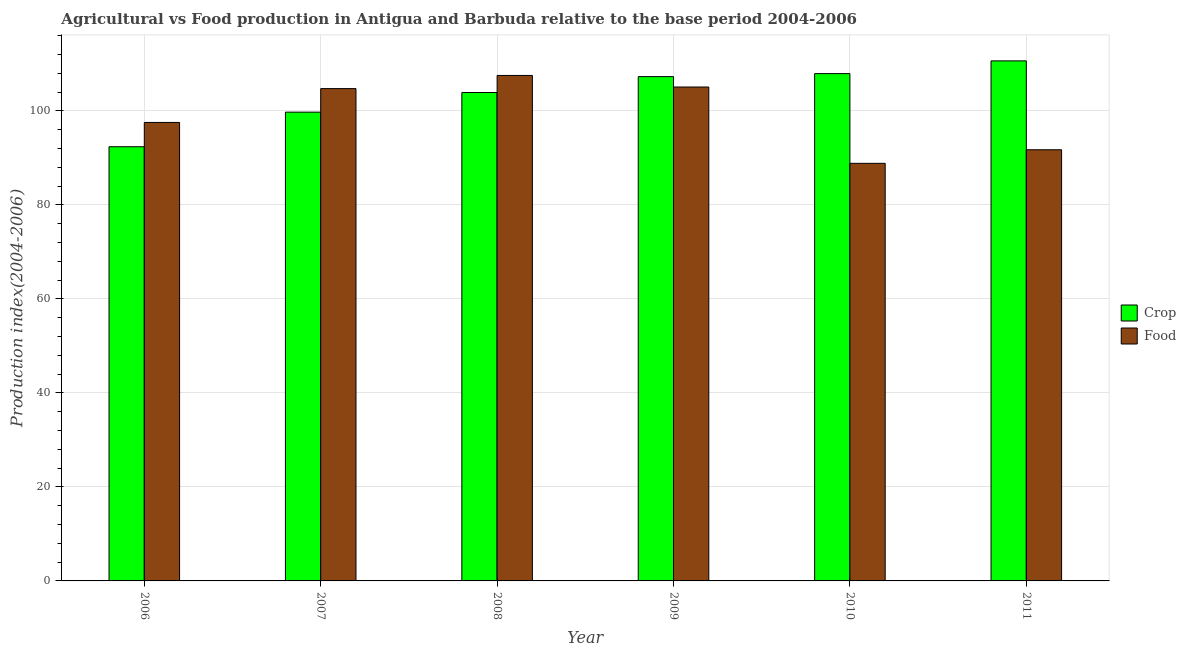How many different coloured bars are there?
Ensure brevity in your answer.  2. How many groups of bars are there?
Give a very brief answer. 6. Are the number of bars per tick equal to the number of legend labels?
Ensure brevity in your answer.  Yes. Are the number of bars on each tick of the X-axis equal?
Make the answer very short. Yes. How many bars are there on the 3rd tick from the left?
Ensure brevity in your answer.  2. What is the label of the 3rd group of bars from the left?
Make the answer very short. 2008. In how many cases, is the number of bars for a given year not equal to the number of legend labels?
Offer a terse response. 0. What is the food production index in 2007?
Your answer should be very brief. 104.75. Across all years, what is the maximum food production index?
Provide a succinct answer. 107.55. Across all years, what is the minimum food production index?
Provide a succinct answer. 88.85. What is the total food production index in the graph?
Keep it short and to the point. 595.53. What is the difference between the food production index in 2006 and that in 2011?
Offer a terse response. 5.81. What is the difference between the food production index in 2011 and the crop production index in 2006?
Make the answer very short. -5.81. What is the average food production index per year?
Ensure brevity in your answer.  99.26. In the year 2011, what is the difference between the food production index and crop production index?
Offer a very short reply. 0. What is the ratio of the food production index in 2006 to that in 2011?
Provide a succinct answer. 1.06. Is the crop production index in 2010 less than that in 2011?
Give a very brief answer. Yes. What is the difference between the highest and the second highest food production index?
Offer a terse response. 2.46. What is the difference between the highest and the lowest food production index?
Give a very brief answer. 18.7. What does the 1st bar from the left in 2010 represents?
Your answer should be very brief. Crop. What does the 1st bar from the right in 2007 represents?
Provide a short and direct response. Food. How many bars are there?
Your response must be concise. 12. Are the values on the major ticks of Y-axis written in scientific E-notation?
Keep it short and to the point. No. Does the graph contain any zero values?
Offer a very short reply. No. How are the legend labels stacked?
Make the answer very short. Vertical. What is the title of the graph?
Provide a succinct answer. Agricultural vs Food production in Antigua and Barbuda relative to the base period 2004-2006. Does "UN agencies" appear as one of the legend labels in the graph?
Give a very brief answer. No. What is the label or title of the Y-axis?
Give a very brief answer. Production index(2004-2006). What is the Production index(2004-2006) of Crop in 2006?
Your answer should be very brief. 92.38. What is the Production index(2004-2006) of Food in 2006?
Make the answer very short. 97.55. What is the Production index(2004-2006) in Crop in 2007?
Keep it short and to the point. 99.74. What is the Production index(2004-2006) of Food in 2007?
Your answer should be compact. 104.75. What is the Production index(2004-2006) in Crop in 2008?
Keep it short and to the point. 103.92. What is the Production index(2004-2006) in Food in 2008?
Ensure brevity in your answer.  107.55. What is the Production index(2004-2006) in Crop in 2009?
Ensure brevity in your answer.  107.3. What is the Production index(2004-2006) in Food in 2009?
Keep it short and to the point. 105.09. What is the Production index(2004-2006) of Crop in 2010?
Offer a terse response. 107.94. What is the Production index(2004-2006) in Food in 2010?
Your answer should be compact. 88.85. What is the Production index(2004-2006) of Crop in 2011?
Your response must be concise. 110.65. What is the Production index(2004-2006) in Food in 2011?
Give a very brief answer. 91.74. Across all years, what is the maximum Production index(2004-2006) in Crop?
Make the answer very short. 110.65. Across all years, what is the maximum Production index(2004-2006) of Food?
Your answer should be compact. 107.55. Across all years, what is the minimum Production index(2004-2006) of Crop?
Your answer should be very brief. 92.38. Across all years, what is the minimum Production index(2004-2006) of Food?
Give a very brief answer. 88.85. What is the total Production index(2004-2006) in Crop in the graph?
Your response must be concise. 621.93. What is the total Production index(2004-2006) in Food in the graph?
Ensure brevity in your answer.  595.53. What is the difference between the Production index(2004-2006) of Crop in 2006 and that in 2007?
Your answer should be compact. -7.36. What is the difference between the Production index(2004-2006) of Crop in 2006 and that in 2008?
Offer a terse response. -11.54. What is the difference between the Production index(2004-2006) of Crop in 2006 and that in 2009?
Offer a terse response. -14.92. What is the difference between the Production index(2004-2006) of Food in 2006 and that in 2009?
Your response must be concise. -7.54. What is the difference between the Production index(2004-2006) in Crop in 2006 and that in 2010?
Your response must be concise. -15.56. What is the difference between the Production index(2004-2006) of Food in 2006 and that in 2010?
Provide a short and direct response. 8.7. What is the difference between the Production index(2004-2006) in Crop in 2006 and that in 2011?
Ensure brevity in your answer.  -18.27. What is the difference between the Production index(2004-2006) in Food in 2006 and that in 2011?
Make the answer very short. 5.81. What is the difference between the Production index(2004-2006) in Crop in 2007 and that in 2008?
Ensure brevity in your answer.  -4.18. What is the difference between the Production index(2004-2006) in Crop in 2007 and that in 2009?
Give a very brief answer. -7.56. What is the difference between the Production index(2004-2006) of Food in 2007 and that in 2009?
Ensure brevity in your answer.  -0.34. What is the difference between the Production index(2004-2006) in Crop in 2007 and that in 2010?
Ensure brevity in your answer.  -8.2. What is the difference between the Production index(2004-2006) of Food in 2007 and that in 2010?
Keep it short and to the point. 15.9. What is the difference between the Production index(2004-2006) of Crop in 2007 and that in 2011?
Make the answer very short. -10.91. What is the difference between the Production index(2004-2006) of Food in 2007 and that in 2011?
Give a very brief answer. 13.01. What is the difference between the Production index(2004-2006) of Crop in 2008 and that in 2009?
Provide a short and direct response. -3.38. What is the difference between the Production index(2004-2006) in Food in 2008 and that in 2009?
Your answer should be very brief. 2.46. What is the difference between the Production index(2004-2006) in Crop in 2008 and that in 2010?
Your answer should be compact. -4.02. What is the difference between the Production index(2004-2006) of Crop in 2008 and that in 2011?
Give a very brief answer. -6.73. What is the difference between the Production index(2004-2006) in Food in 2008 and that in 2011?
Give a very brief answer. 15.81. What is the difference between the Production index(2004-2006) in Crop in 2009 and that in 2010?
Provide a short and direct response. -0.64. What is the difference between the Production index(2004-2006) in Food in 2009 and that in 2010?
Offer a very short reply. 16.24. What is the difference between the Production index(2004-2006) in Crop in 2009 and that in 2011?
Provide a short and direct response. -3.35. What is the difference between the Production index(2004-2006) in Food in 2009 and that in 2011?
Ensure brevity in your answer.  13.35. What is the difference between the Production index(2004-2006) in Crop in 2010 and that in 2011?
Ensure brevity in your answer.  -2.71. What is the difference between the Production index(2004-2006) of Food in 2010 and that in 2011?
Provide a short and direct response. -2.89. What is the difference between the Production index(2004-2006) in Crop in 2006 and the Production index(2004-2006) in Food in 2007?
Offer a terse response. -12.37. What is the difference between the Production index(2004-2006) of Crop in 2006 and the Production index(2004-2006) of Food in 2008?
Give a very brief answer. -15.17. What is the difference between the Production index(2004-2006) in Crop in 2006 and the Production index(2004-2006) in Food in 2009?
Make the answer very short. -12.71. What is the difference between the Production index(2004-2006) in Crop in 2006 and the Production index(2004-2006) in Food in 2010?
Keep it short and to the point. 3.53. What is the difference between the Production index(2004-2006) in Crop in 2006 and the Production index(2004-2006) in Food in 2011?
Keep it short and to the point. 0.64. What is the difference between the Production index(2004-2006) of Crop in 2007 and the Production index(2004-2006) of Food in 2008?
Your answer should be very brief. -7.81. What is the difference between the Production index(2004-2006) of Crop in 2007 and the Production index(2004-2006) of Food in 2009?
Offer a terse response. -5.35. What is the difference between the Production index(2004-2006) of Crop in 2007 and the Production index(2004-2006) of Food in 2010?
Ensure brevity in your answer.  10.89. What is the difference between the Production index(2004-2006) in Crop in 2008 and the Production index(2004-2006) in Food in 2009?
Your response must be concise. -1.17. What is the difference between the Production index(2004-2006) of Crop in 2008 and the Production index(2004-2006) of Food in 2010?
Offer a terse response. 15.07. What is the difference between the Production index(2004-2006) of Crop in 2008 and the Production index(2004-2006) of Food in 2011?
Ensure brevity in your answer.  12.18. What is the difference between the Production index(2004-2006) in Crop in 2009 and the Production index(2004-2006) in Food in 2010?
Offer a very short reply. 18.45. What is the difference between the Production index(2004-2006) of Crop in 2009 and the Production index(2004-2006) of Food in 2011?
Your response must be concise. 15.56. What is the average Production index(2004-2006) of Crop per year?
Your answer should be very brief. 103.66. What is the average Production index(2004-2006) of Food per year?
Your response must be concise. 99.25. In the year 2006, what is the difference between the Production index(2004-2006) of Crop and Production index(2004-2006) of Food?
Offer a very short reply. -5.17. In the year 2007, what is the difference between the Production index(2004-2006) of Crop and Production index(2004-2006) of Food?
Offer a terse response. -5.01. In the year 2008, what is the difference between the Production index(2004-2006) of Crop and Production index(2004-2006) of Food?
Your answer should be compact. -3.63. In the year 2009, what is the difference between the Production index(2004-2006) in Crop and Production index(2004-2006) in Food?
Your answer should be very brief. 2.21. In the year 2010, what is the difference between the Production index(2004-2006) of Crop and Production index(2004-2006) of Food?
Your answer should be compact. 19.09. In the year 2011, what is the difference between the Production index(2004-2006) of Crop and Production index(2004-2006) of Food?
Make the answer very short. 18.91. What is the ratio of the Production index(2004-2006) in Crop in 2006 to that in 2007?
Provide a succinct answer. 0.93. What is the ratio of the Production index(2004-2006) of Food in 2006 to that in 2007?
Offer a very short reply. 0.93. What is the ratio of the Production index(2004-2006) in Crop in 2006 to that in 2008?
Your answer should be very brief. 0.89. What is the ratio of the Production index(2004-2006) of Food in 2006 to that in 2008?
Give a very brief answer. 0.91. What is the ratio of the Production index(2004-2006) in Crop in 2006 to that in 2009?
Keep it short and to the point. 0.86. What is the ratio of the Production index(2004-2006) of Food in 2006 to that in 2009?
Give a very brief answer. 0.93. What is the ratio of the Production index(2004-2006) in Crop in 2006 to that in 2010?
Keep it short and to the point. 0.86. What is the ratio of the Production index(2004-2006) of Food in 2006 to that in 2010?
Offer a terse response. 1.1. What is the ratio of the Production index(2004-2006) of Crop in 2006 to that in 2011?
Make the answer very short. 0.83. What is the ratio of the Production index(2004-2006) in Food in 2006 to that in 2011?
Make the answer very short. 1.06. What is the ratio of the Production index(2004-2006) of Crop in 2007 to that in 2008?
Provide a succinct answer. 0.96. What is the ratio of the Production index(2004-2006) of Crop in 2007 to that in 2009?
Offer a terse response. 0.93. What is the ratio of the Production index(2004-2006) of Food in 2007 to that in 2009?
Give a very brief answer. 1. What is the ratio of the Production index(2004-2006) in Crop in 2007 to that in 2010?
Your response must be concise. 0.92. What is the ratio of the Production index(2004-2006) of Food in 2007 to that in 2010?
Offer a very short reply. 1.18. What is the ratio of the Production index(2004-2006) of Crop in 2007 to that in 2011?
Provide a succinct answer. 0.9. What is the ratio of the Production index(2004-2006) of Food in 2007 to that in 2011?
Provide a succinct answer. 1.14. What is the ratio of the Production index(2004-2006) in Crop in 2008 to that in 2009?
Give a very brief answer. 0.97. What is the ratio of the Production index(2004-2006) of Food in 2008 to that in 2009?
Provide a succinct answer. 1.02. What is the ratio of the Production index(2004-2006) of Crop in 2008 to that in 2010?
Your response must be concise. 0.96. What is the ratio of the Production index(2004-2006) of Food in 2008 to that in 2010?
Give a very brief answer. 1.21. What is the ratio of the Production index(2004-2006) in Crop in 2008 to that in 2011?
Provide a succinct answer. 0.94. What is the ratio of the Production index(2004-2006) in Food in 2008 to that in 2011?
Your answer should be compact. 1.17. What is the ratio of the Production index(2004-2006) of Food in 2009 to that in 2010?
Your answer should be compact. 1.18. What is the ratio of the Production index(2004-2006) of Crop in 2009 to that in 2011?
Offer a terse response. 0.97. What is the ratio of the Production index(2004-2006) of Food in 2009 to that in 2011?
Provide a succinct answer. 1.15. What is the ratio of the Production index(2004-2006) of Crop in 2010 to that in 2011?
Make the answer very short. 0.98. What is the ratio of the Production index(2004-2006) of Food in 2010 to that in 2011?
Your response must be concise. 0.97. What is the difference between the highest and the second highest Production index(2004-2006) of Crop?
Your answer should be compact. 2.71. What is the difference between the highest and the second highest Production index(2004-2006) in Food?
Offer a very short reply. 2.46. What is the difference between the highest and the lowest Production index(2004-2006) in Crop?
Offer a terse response. 18.27. What is the difference between the highest and the lowest Production index(2004-2006) in Food?
Your answer should be very brief. 18.7. 